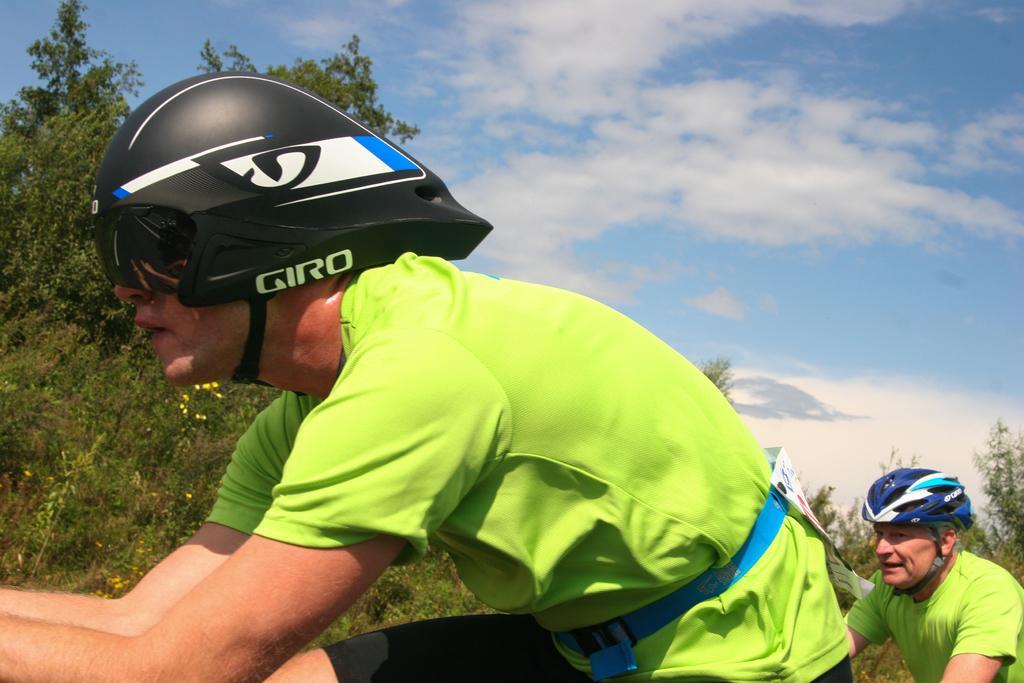Describe this image in one or two sentences. In the foreground of this image, there are two men in green T shirt wearing helmets and a man is having poster to his waist. In the background, there are trees, sky and the cloud. 